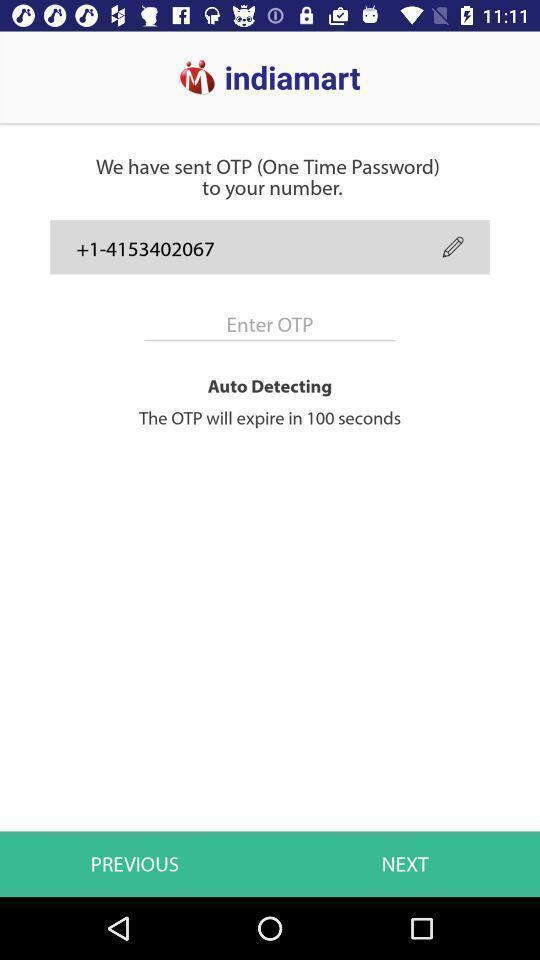Explain the elements present in this screenshot. Page displaying to enter the otp. 